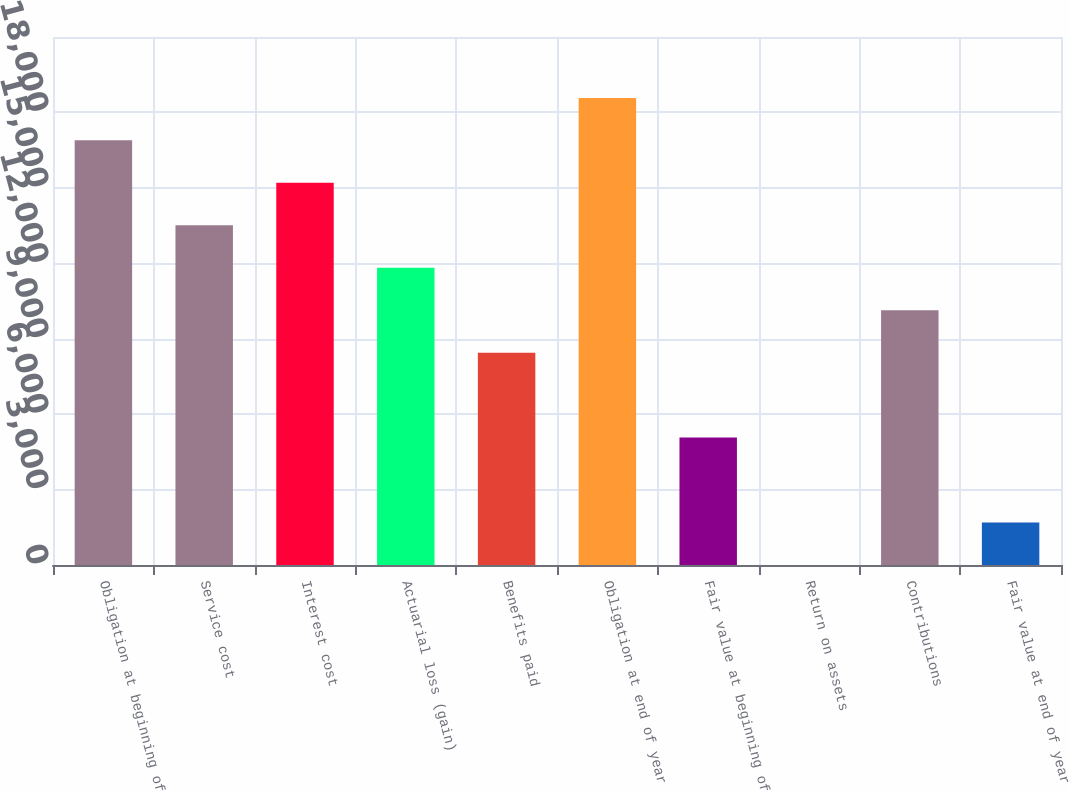Convert chart to OTSL. <chart><loc_0><loc_0><loc_500><loc_500><bar_chart><fcel>Obligation at beginning of<fcel>Service cost<fcel>Interest cost<fcel>Actuarial loss (gain)<fcel>Benefits paid<fcel>Obligation at end of year<fcel>Fair value at beginning of<fcel>Return on assets<fcel>Contributions<fcel>Fair value at end of year<nl><fcel>16889<fcel>13511.4<fcel>15200.2<fcel>11822.6<fcel>8445.11<fcel>18577.7<fcel>5067.57<fcel>1.26<fcel>10133.9<fcel>1690.03<nl></chart> 